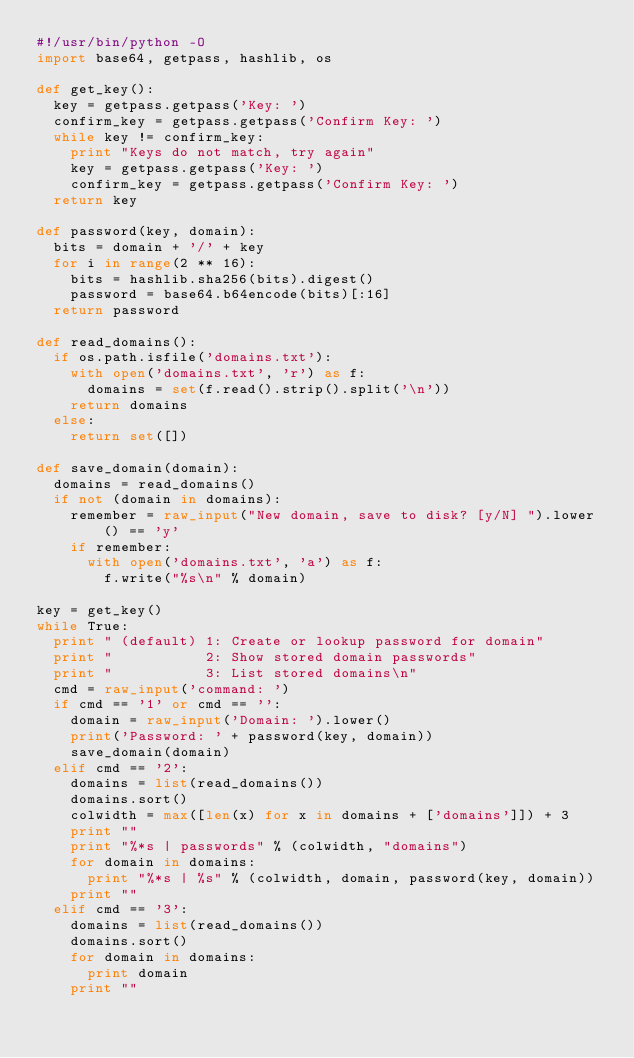<code> <loc_0><loc_0><loc_500><loc_500><_Python_>#!/usr/bin/python -O
import base64, getpass, hashlib, os

def get_key():
  key = getpass.getpass('Key: ')
  confirm_key = getpass.getpass('Confirm Key: ')
  while key != confirm_key:
    print "Keys do not match, try again"
    key = getpass.getpass('Key: ')
    confirm_key = getpass.getpass('Confirm Key: ')
  return key

def password(key, domain):
  bits = domain + '/' + key
  for i in range(2 ** 16):
    bits = hashlib.sha256(bits).digest()
    password = base64.b64encode(bits)[:16]
  return password

def read_domains():
  if os.path.isfile('domains.txt'):
    with open('domains.txt', 'r') as f:
      domains = set(f.read().strip().split('\n'))
    return domains
  else:
    return set([])

def save_domain(domain):
  domains = read_domains()
  if not (domain in domains):
    remember = raw_input("New domain, save to disk? [y/N] ").lower() == 'y'
    if remember:
      with open('domains.txt', 'a') as f:
        f.write("%s\n" % domain)

key = get_key()
while True:
  print " (default) 1: Create or lookup password for domain"
  print "           2: Show stored domain passwords"
  print "           3: List stored domains\n"
  cmd = raw_input('command: ')
  if cmd == '1' or cmd == '':
    domain = raw_input('Domain: ').lower()
    print('Password: ' + password(key, domain))
    save_domain(domain)
  elif cmd == '2':
    domains = list(read_domains())
    domains.sort()
    colwidth = max([len(x) for x in domains + ['domains']]) + 3
    print ""
    print "%*s | passwords" % (colwidth, "domains")
    for domain in domains:
      print "%*s | %s" % (colwidth, domain, password(key, domain))
    print ""
  elif cmd == '3':
    domains = list(read_domains())
    domains.sort()
    for domain in domains:
      print domain
    print ""
</code> 